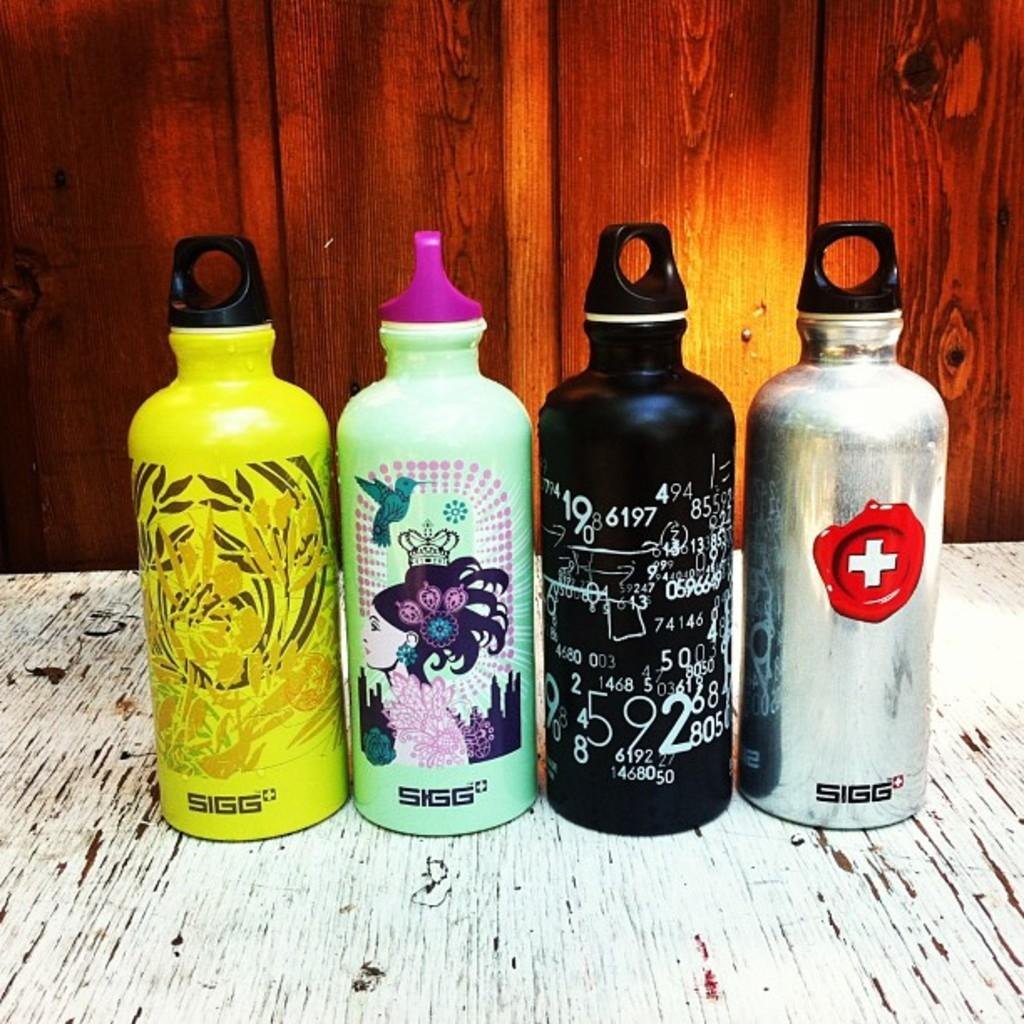<image>
Summarize the visual content of the image. Four different water bottles from SIGG lined up 